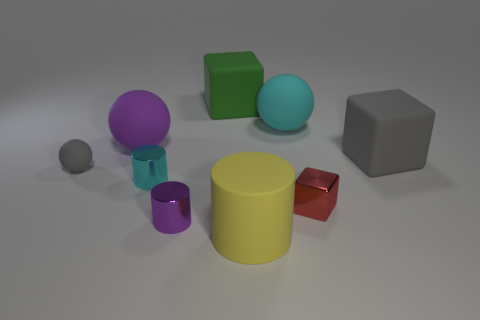What textures does the surface have where the objects are placed? The surface upon which the objects are placed appears smooth and doesn't exhibit any distinct textures. 